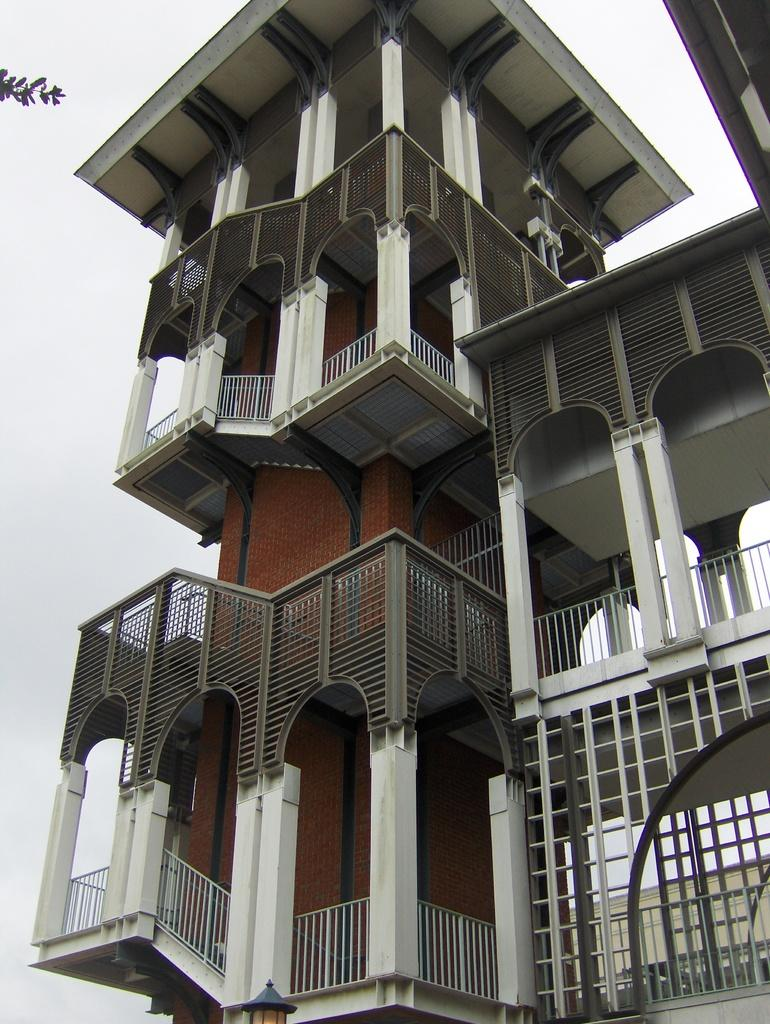What is the main subject of the image? The main subject of the image is a building. What colors are used for the building? The building is in white and brown color. What can be seen in the background of the image? There is a sky visible in the background of the image. What type of vacation is being advertised in the image? There is no indication of a vacation being advertised in the image; it simply features a building with a white and brown color scheme. Where is the oven located in the image? There is no oven present in the image. 